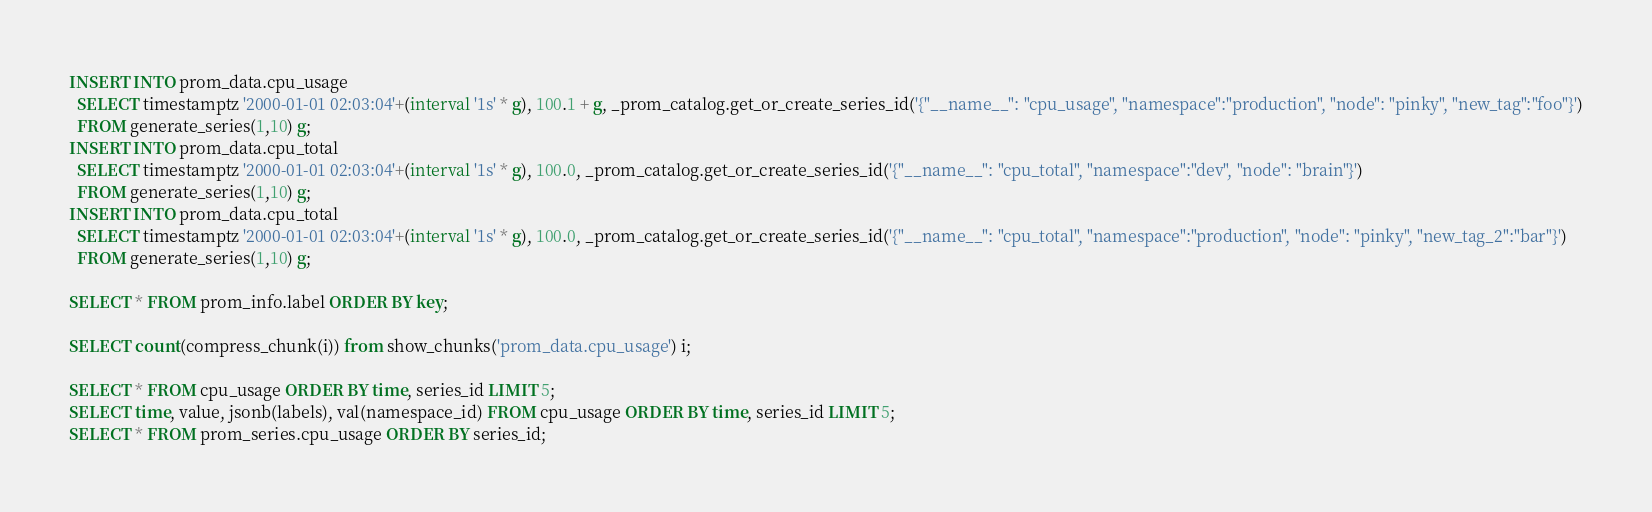Convert code to text. <code><loc_0><loc_0><loc_500><loc_500><_SQL_>INSERT INTO prom_data.cpu_usage
  SELECT timestamptz '2000-01-01 02:03:04'+(interval '1s' * g), 100.1 + g, _prom_catalog.get_or_create_series_id('{"__name__": "cpu_usage", "namespace":"production", "node": "pinky", "new_tag":"foo"}')
  FROM generate_series(1,10) g;
INSERT INTO prom_data.cpu_total
  SELECT timestamptz '2000-01-01 02:03:04'+(interval '1s' * g), 100.0, _prom_catalog.get_or_create_series_id('{"__name__": "cpu_total", "namespace":"dev", "node": "brain"}')
  FROM generate_series(1,10) g;
INSERT INTO prom_data.cpu_total
  SELECT timestamptz '2000-01-01 02:03:04'+(interval '1s' * g), 100.0, _prom_catalog.get_or_create_series_id('{"__name__": "cpu_total", "namespace":"production", "node": "pinky", "new_tag_2":"bar"}')
  FROM generate_series(1,10) g;

SELECT * FROM prom_info.label ORDER BY key;

SELECT count(compress_chunk(i)) from show_chunks('prom_data.cpu_usage') i;

SELECT * FROM cpu_usage ORDER BY time, series_id LIMIT 5;
SELECT time, value, jsonb(labels), val(namespace_id) FROM cpu_usage ORDER BY time, series_id LIMIT 5;
SELECT * FROM prom_series.cpu_usage ORDER BY series_id;</code> 